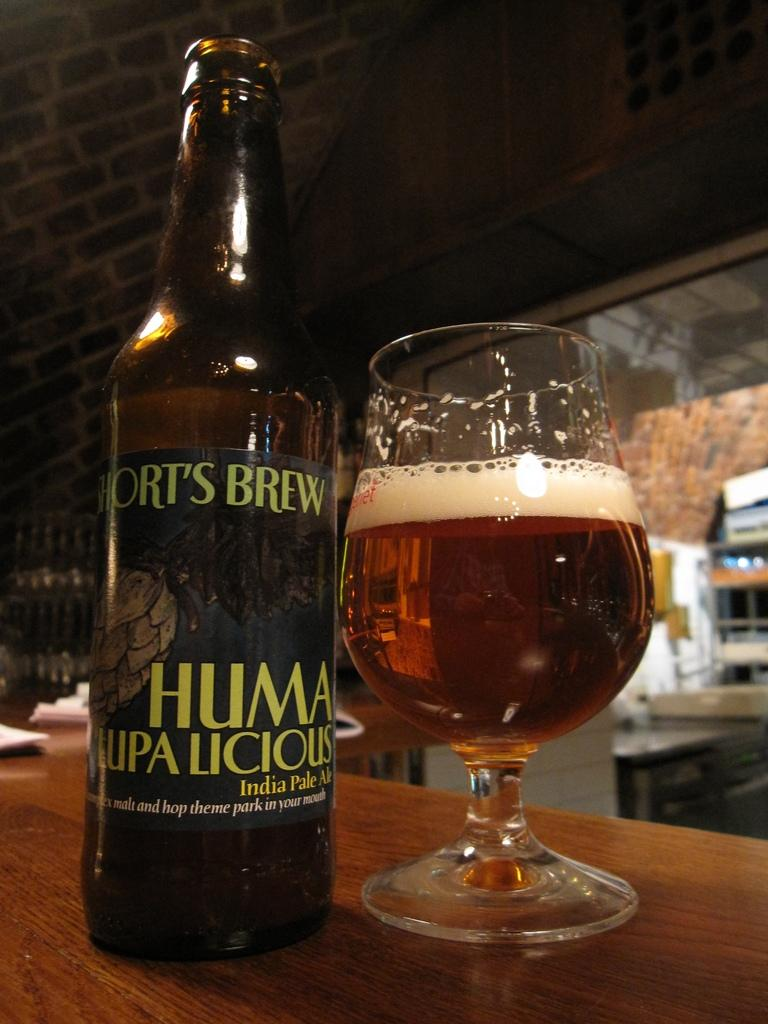What is on the table in the image? There is a wine bottle and a glass on the table. What is the background of the image? The table is in front of a brick wall. What type of stitch is used to create the wine bottle in the image? There is no stitch involved in creating a wine bottle; it is a manufactured product. 